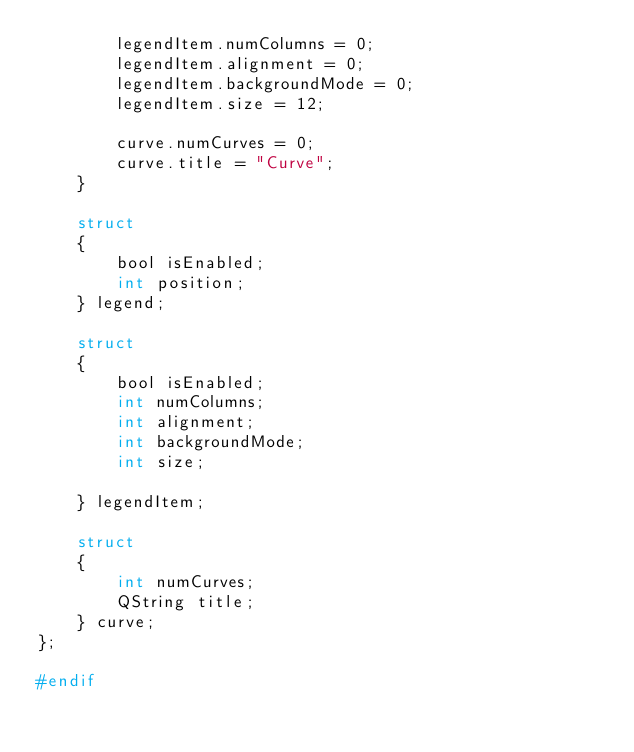Convert code to text. <code><loc_0><loc_0><loc_500><loc_500><_C_>        legendItem.numColumns = 0;
        legendItem.alignment = 0;
        legendItem.backgroundMode = 0;
        legendItem.size = 12;

        curve.numCurves = 0;
        curve.title = "Curve";
    }
    
    struct
    {
        bool isEnabled;
        int position;
    } legend;

    struct
    {
        bool isEnabled;
        int numColumns;
        int alignment;
        int backgroundMode;
        int size;
        
    } legendItem;
    
    struct
    {
        int numCurves;
        QString title;
    } curve;
};

#endif
</code> 